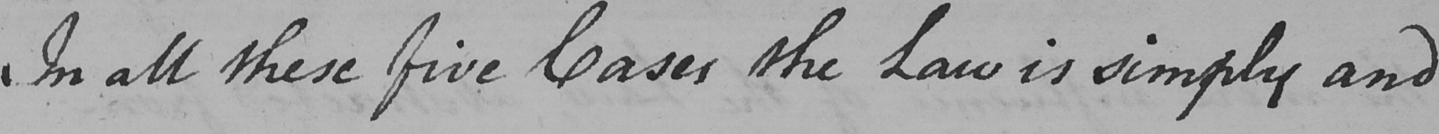What text is written in this handwritten line? In all these five Cases the Law is simply and 